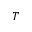<formula> <loc_0><loc_0><loc_500><loc_500>T</formula> 